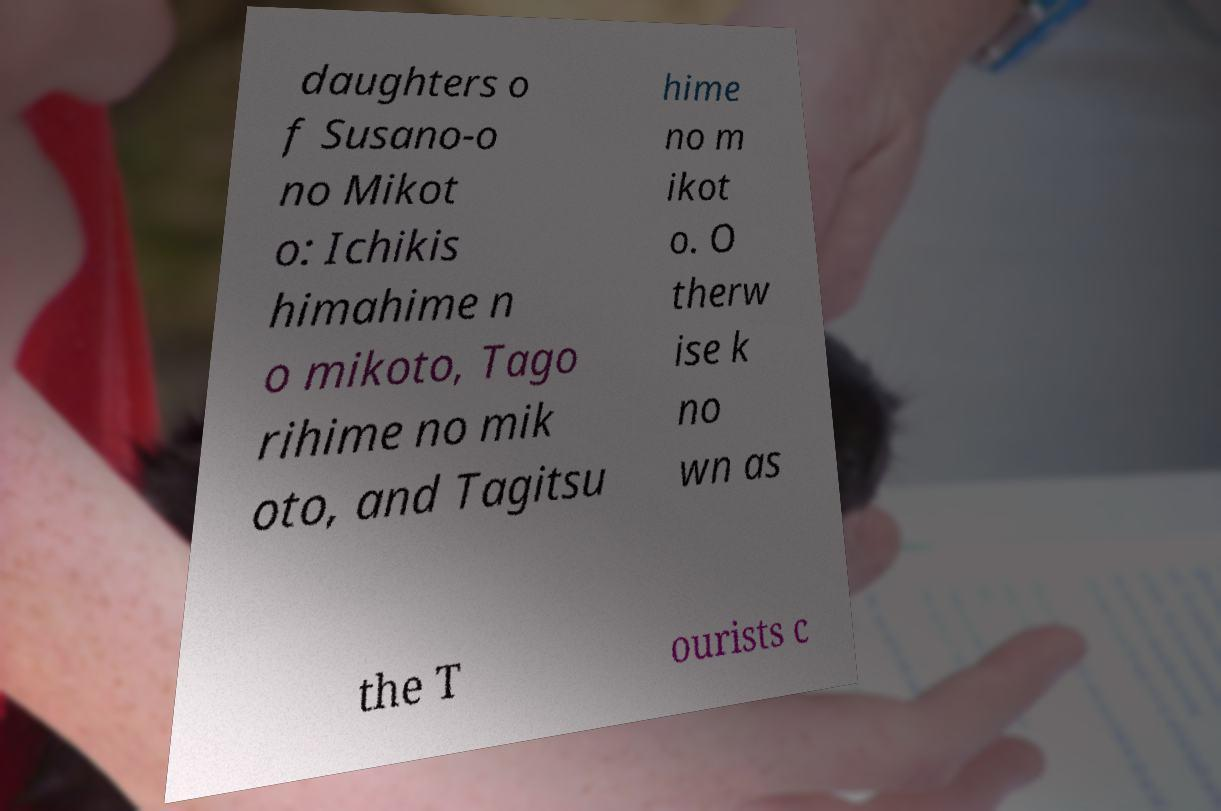Please identify and transcribe the text found in this image. daughters o f Susano-o no Mikot o: Ichikis himahime n o mikoto, Tago rihime no mik oto, and Tagitsu hime no m ikot o. O therw ise k no wn as the T ourists c 